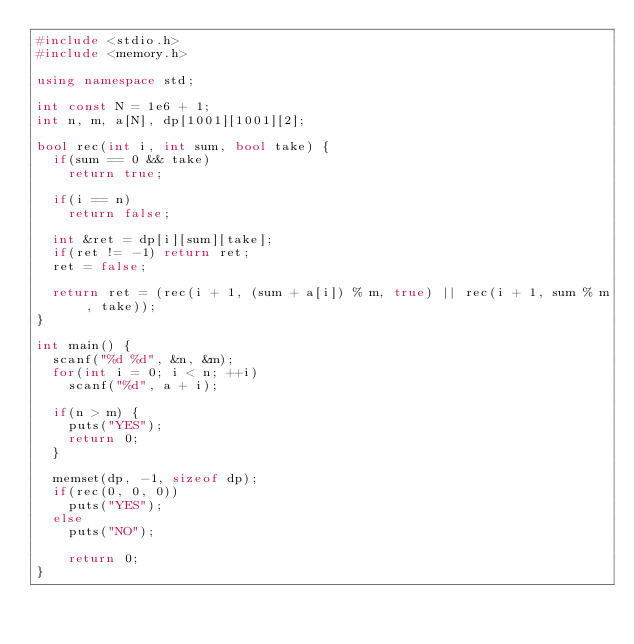Convert code to text. <code><loc_0><loc_0><loc_500><loc_500><_C++_>#include <stdio.h>
#include <memory.h>

using namespace std;

int const N = 1e6 + 1;
int n, m, a[N], dp[1001][1001][2];

bool rec(int i, int sum, bool take) {
	if(sum == 0 && take)
		return true;

	if(i == n)
		return false;

	int &ret = dp[i][sum][take];
	if(ret != -1) return ret;
	ret = false;

	return ret = (rec(i + 1, (sum + a[i]) % m, true) || rec(i + 1, sum % m, take));
}

int main() {
	scanf("%d %d", &n, &m);
	for(int i = 0; i < n; ++i)
		scanf("%d", a + i);

	if(n > m) {
		puts("YES");
		return 0;
	}

	memset(dp, -1, sizeof dp);
	if(rec(0, 0, 0))
		puts("YES");
	else
		puts("NO");

    return 0;
}

</code> 